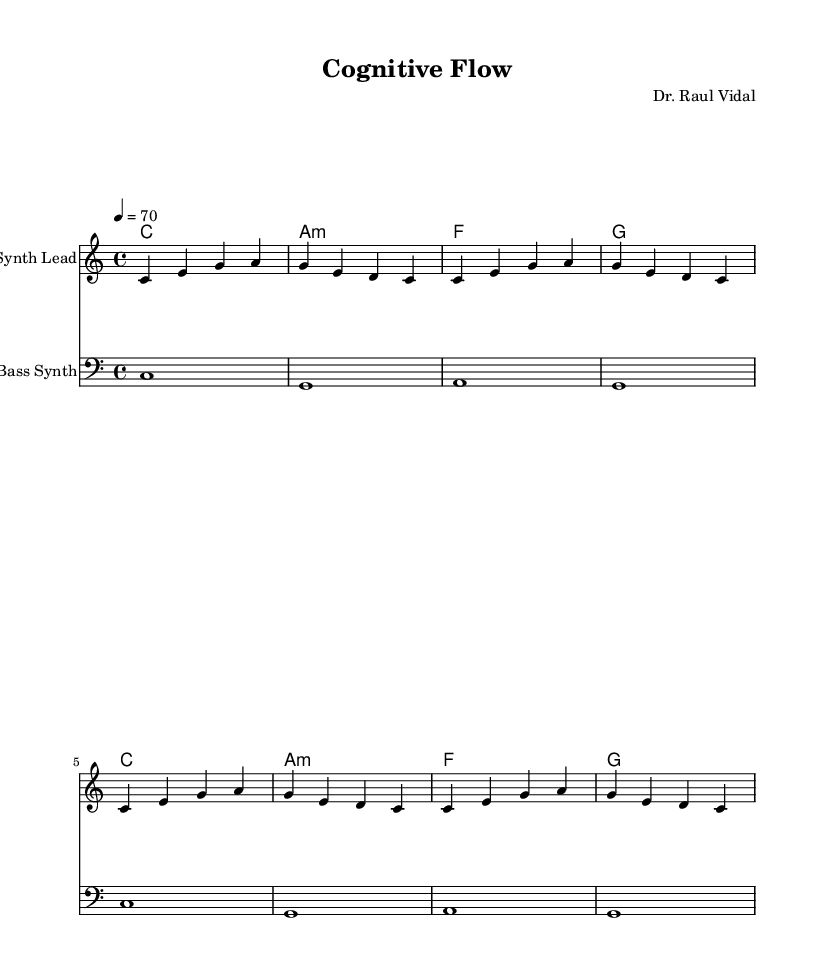What is the key signature of this music? The key signature indicates the notes used in the piece, and in this case, it is C major, which has no sharps or flats. This can be seen in the 'global' section where it specifies \key c \major.
Answer: C major What is the time signature of this music? The time signature specifies the number of beats in each measure and the type of note that gets the beat. Here, it is 4/4, which means there are four beats per measure and the quarter note gets one beat, as indicated by \time 4/4 in the 'global' section.
Answer: 4/4 What is the tempo marking of the piece? The tempo marking gives the speed at which the piece should be performed. It is set to 70 beats per minute, as noted in the 'global' section with \tempo 4 = 70.
Answer: 70 How many measures are there in the melody? To find the number of measures, we can count the groups of notes in the melody section, which is defined within the structure. Each set of four beats (as per 4/4 time) represents one measure. There are eight groups of four notes, thus there are eight measures.
Answer: 8 What chords are used in the harmony? The chord progression can be found in the ‘harmony’ section of the code. The chords listed are C major (C), A minor (Am), F major (F), and G major (G), providing a simple harmonic structure for this ambient electronic piece.
Answer: C, A minor, F, G What clef is used in the bass part? The clef indicates the pitch range for the staff, and here, the clef specified is the bass clef, as denoted by \clef bass in the bass section of the composition.
Answer: Bass clef What instrument does the melody represent? The melody is played on the Synth Lead, which is indicated in the staff label 'instrumentName' in the section that defines the melody part. This specific instrument is common in ambient electronic music for its smooth sound.
Answer: Synth Lead 